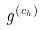Convert formula to latex. <formula><loc_0><loc_0><loc_500><loc_500>g ^ { ( c _ { h } ) }</formula> 